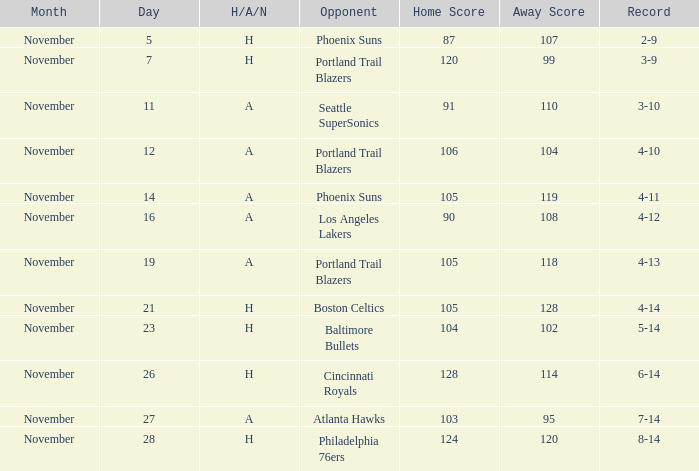What was the Opponent when the Cavaliers had a Record of 3-9? Portland Trail Blazers. 